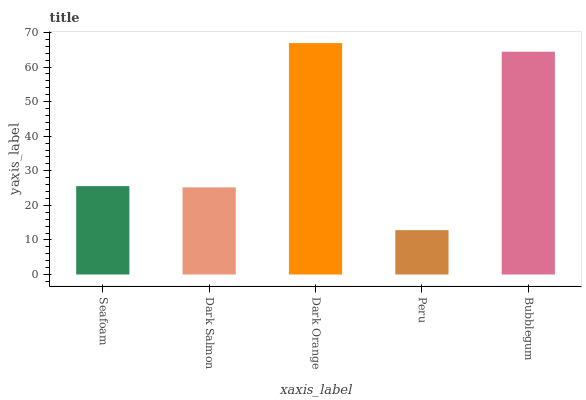Is Peru the minimum?
Answer yes or no. Yes. Is Dark Orange the maximum?
Answer yes or no. Yes. Is Dark Salmon the minimum?
Answer yes or no. No. Is Dark Salmon the maximum?
Answer yes or no. No. Is Seafoam greater than Dark Salmon?
Answer yes or no. Yes. Is Dark Salmon less than Seafoam?
Answer yes or no. Yes. Is Dark Salmon greater than Seafoam?
Answer yes or no. No. Is Seafoam less than Dark Salmon?
Answer yes or no. No. Is Seafoam the high median?
Answer yes or no. Yes. Is Seafoam the low median?
Answer yes or no. Yes. Is Peru the high median?
Answer yes or no. No. Is Dark Salmon the low median?
Answer yes or no. No. 